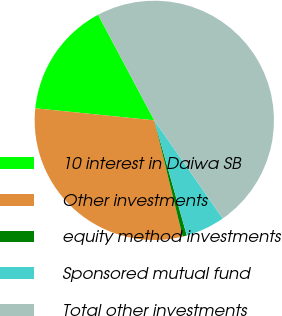Convert chart to OTSL. <chart><loc_0><loc_0><loc_500><loc_500><pie_chart><fcel>10 interest in Daiwa SB<fcel>Other investments<fcel>equity method investments<fcel>Sponsored mutual fund<fcel>Total other investments<nl><fcel>15.61%<fcel>30.41%<fcel>0.57%<fcel>5.32%<fcel>48.08%<nl></chart> 